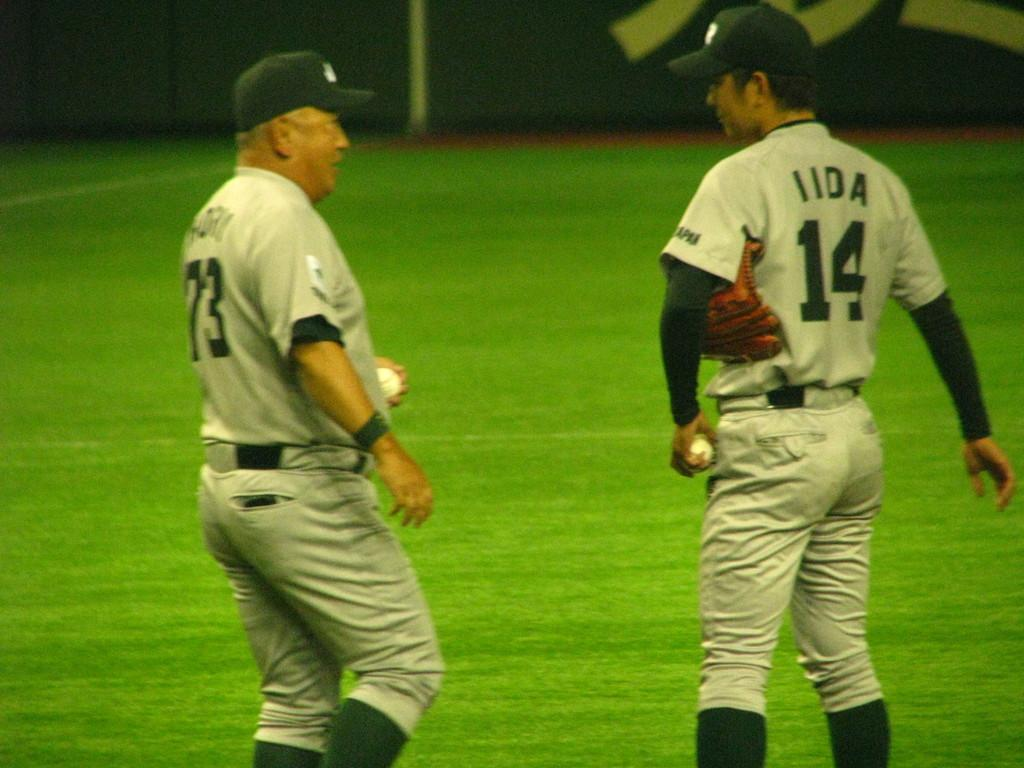<image>
Create a compact narrative representing the image presented. A man in a number 14 baseball jersey talks to another man in a 73 jersey. 